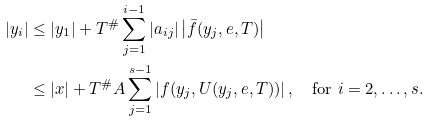<formula> <loc_0><loc_0><loc_500><loc_500>| y _ { i } | & \leq | y _ { 1 } | + T ^ { \# } \sum _ { j = 1 } ^ { i - 1 } | a _ { i j } | \left | \bar { f } ( y _ { j } , e , T ) \right | \\ & \leq | x | + T ^ { \# } A \sum _ { j = 1 } ^ { s - 1 } \left | f ( y _ { j } , U ( y _ { j } , e , T ) ) \right | , \quad \text {for } i = 2 , \dots , s .</formula> 